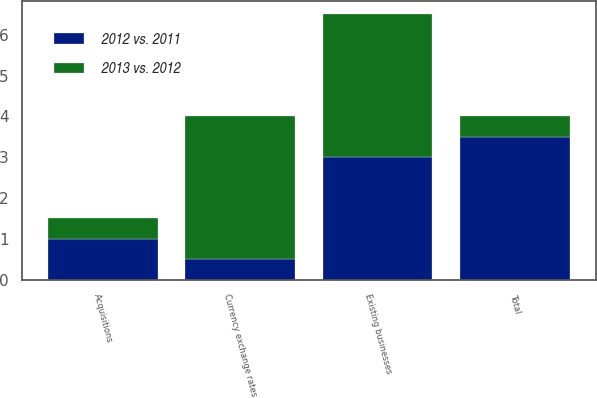Convert chart to OTSL. <chart><loc_0><loc_0><loc_500><loc_500><stacked_bar_chart><ecel><fcel>Existing businesses<fcel>Acquisitions<fcel>Currency exchange rates<fcel>Total<nl><fcel>2012 vs. 2011<fcel>3<fcel>1<fcel>0.5<fcel>3.5<nl><fcel>2013 vs. 2012<fcel>3.5<fcel>0.5<fcel>3.5<fcel>0.5<nl></chart> 